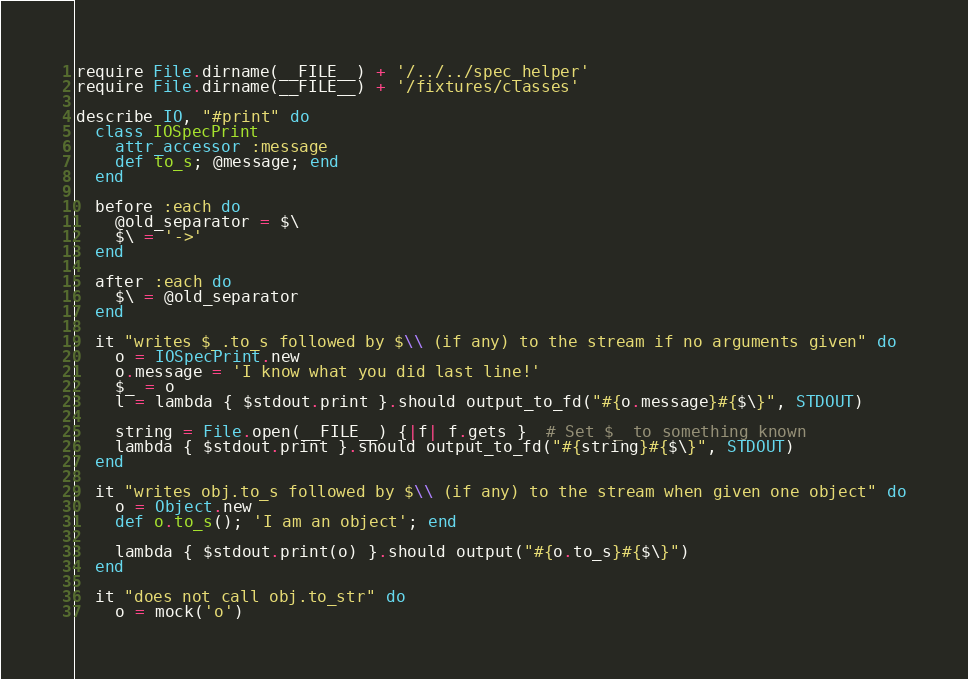Convert code to text. <code><loc_0><loc_0><loc_500><loc_500><_Ruby_>require File.dirname(__FILE__) + '/../../spec_helper'
require File.dirname(__FILE__) + '/fixtures/classes'

describe IO, "#print" do
  class IOSpecPrint
    attr_accessor :message
    def to_s; @message; end
  end

  before :each do
    @old_separator = $\
    $\ = '->'
  end

  after :each do
    $\ = @old_separator
  end

  it "writes $_.to_s followed by $\\ (if any) to the stream if no arguments given" do
    o = IOSpecPrint.new
    o.message = 'I know what you did last line!'
    $_ = o
    l = lambda { $stdout.print }.should output_to_fd("#{o.message}#{$\}", STDOUT)

    string = File.open(__FILE__) {|f| f.gets }  # Set $_ to something known
    lambda { $stdout.print }.should output_to_fd("#{string}#{$\}", STDOUT)
  end

  it "writes obj.to_s followed by $\\ (if any) to the stream when given one object" do
    o = Object.new
    def o.to_s(); 'I am an object'; end

    lambda { $stdout.print(o) }.should output("#{o.to_s}#{$\}")
  end

  it "does not call obj.to_str" do
    o = mock('o')</code> 